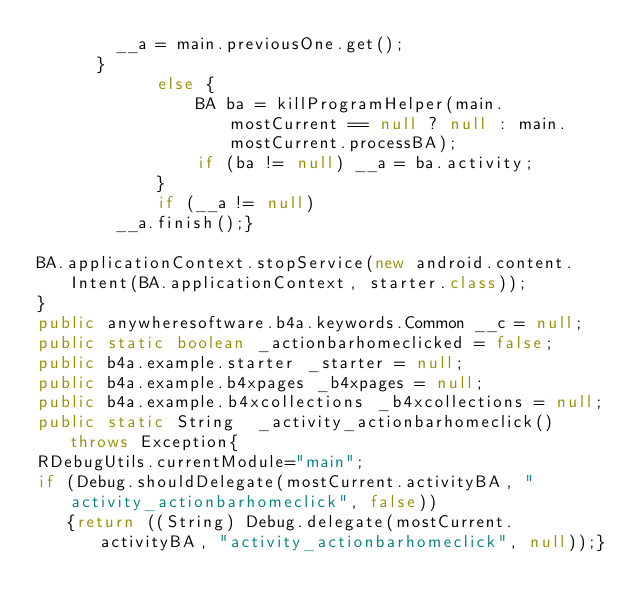Convert code to text. <code><loc_0><loc_0><loc_500><loc_500><_Java_>				__a = main.previousOne.get();
			}
            else {
                BA ba = killProgramHelper(main.mostCurrent == null ? null : main.mostCurrent.processBA);
                if (ba != null) __a = ba.activity;
            }
            if (__a != null)
				__a.finish();}

BA.applicationContext.stopService(new android.content.Intent(BA.applicationContext, starter.class));
}
public anywheresoftware.b4a.keywords.Common __c = null;
public static boolean _actionbarhomeclicked = false;
public b4a.example.starter _starter = null;
public b4a.example.b4xpages _b4xpages = null;
public b4a.example.b4xcollections _b4xcollections = null;
public static String  _activity_actionbarhomeclick() throws Exception{
RDebugUtils.currentModule="main";
if (Debug.shouldDelegate(mostCurrent.activityBA, "activity_actionbarhomeclick", false))
	 {return ((String) Debug.delegate(mostCurrent.activityBA, "activity_actionbarhomeclick", null));}</code> 